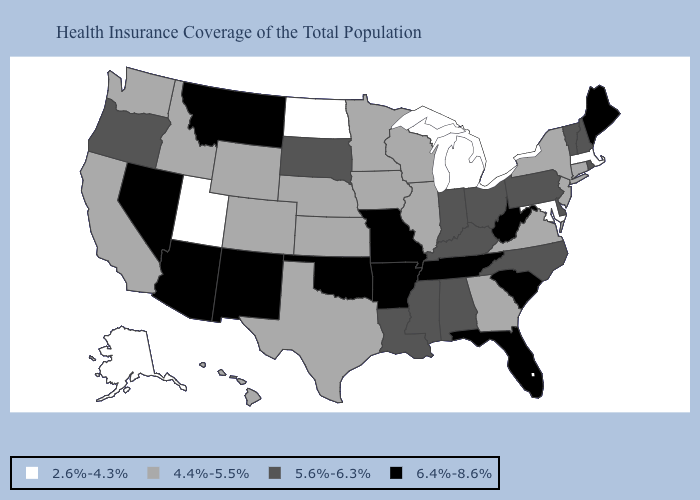What is the value of Arkansas?
Be succinct. 6.4%-8.6%. Among the states that border Ohio , which have the highest value?
Give a very brief answer. West Virginia. Does New York have a higher value than Michigan?
Be succinct. Yes. Which states hav the highest value in the MidWest?
Write a very short answer. Missouri. Among the states that border Florida , which have the lowest value?
Keep it brief. Georgia. Name the states that have a value in the range 4.4%-5.5%?
Give a very brief answer. California, Colorado, Connecticut, Georgia, Hawaii, Idaho, Illinois, Iowa, Kansas, Minnesota, Nebraska, New Jersey, New York, Texas, Virginia, Washington, Wisconsin, Wyoming. Name the states that have a value in the range 6.4%-8.6%?
Keep it brief. Arizona, Arkansas, Florida, Maine, Missouri, Montana, Nevada, New Mexico, Oklahoma, South Carolina, Tennessee, West Virginia. How many symbols are there in the legend?
Concise answer only. 4. What is the value of Nevada?
Keep it brief. 6.4%-8.6%. Which states have the lowest value in the MidWest?
Quick response, please. Michigan, North Dakota. Does Rhode Island have a lower value than Maine?
Answer briefly. Yes. Does Mississippi have a lower value than Hawaii?
Give a very brief answer. No. Name the states that have a value in the range 6.4%-8.6%?
Keep it brief. Arizona, Arkansas, Florida, Maine, Missouri, Montana, Nevada, New Mexico, Oklahoma, South Carolina, Tennessee, West Virginia. Does the first symbol in the legend represent the smallest category?
Give a very brief answer. Yes. Name the states that have a value in the range 5.6%-6.3%?
Short answer required. Alabama, Delaware, Indiana, Kentucky, Louisiana, Mississippi, New Hampshire, North Carolina, Ohio, Oregon, Pennsylvania, Rhode Island, South Dakota, Vermont. 